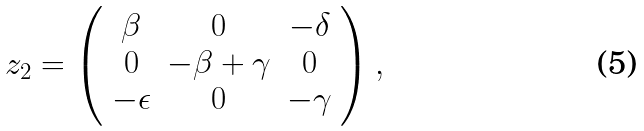Convert formula to latex. <formula><loc_0><loc_0><loc_500><loc_500>\begin{array} { l l l l l l l } z _ { 2 } = \left ( \begin{array} { c c c } \beta & 0 & - \delta \\ 0 & - \beta + \gamma & 0 \\ - \epsilon & 0 & - \gamma \end{array} \right ) , \end{array}</formula> 